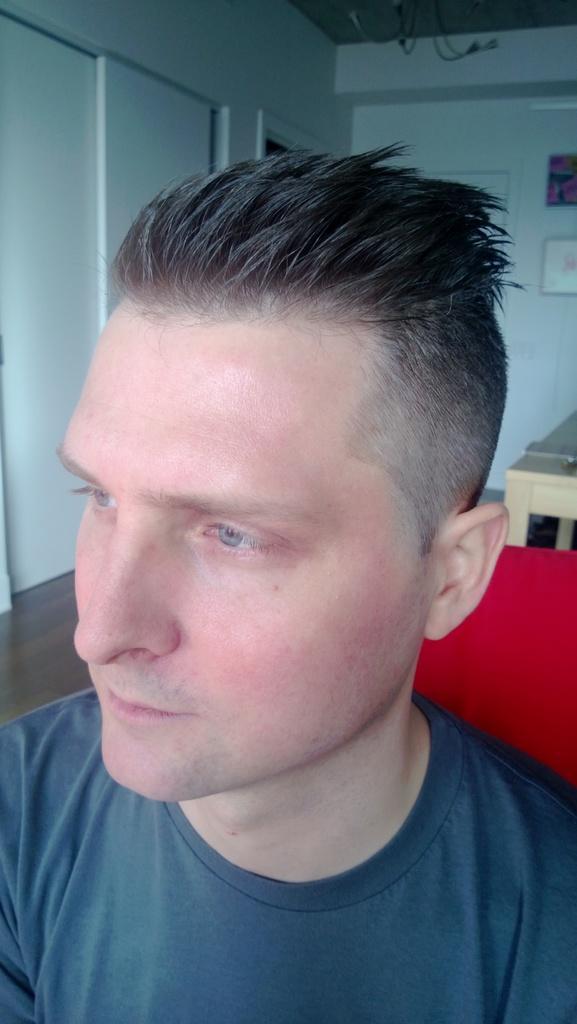How would you summarize this image in a sentence or two? There is a man wearing t shirt. In the back there is a table, wall. On the wall something is there. 